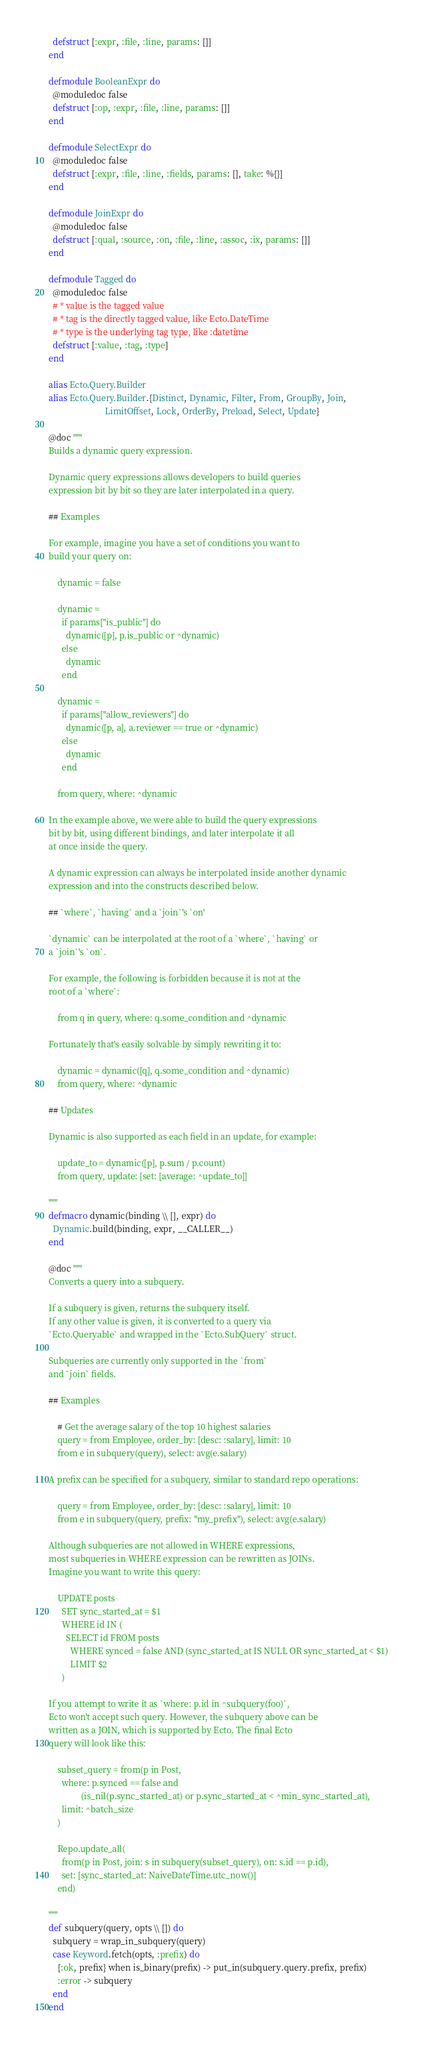Convert code to text. <code><loc_0><loc_0><loc_500><loc_500><_Elixir_>    defstruct [:expr, :file, :line, params: []]
  end

  defmodule BooleanExpr do
    @moduledoc false
    defstruct [:op, :expr, :file, :line, params: []]
  end

  defmodule SelectExpr do
    @moduledoc false
    defstruct [:expr, :file, :line, :fields, params: [], take: %{}]
  end

  defmodule JoinExpr do
    @moduledoc false
    defstruct [:qual, :source, :on, :file, :line, :assoc, :ix, params: []]
  end

  defmodule Tagged do
    @moduledoc false
    # * value is the tagged value
    # * tag is the directly tagged value, like Ecto.DateTime
    # * type is the underlying tag type, like :datetime
    defstruct [:value, :tag, :type]
  end

  alias Ecto.Query.Builder
  alias Ecto.Query.Builder.{Distinct, Dynamic, Filter, From, GroupBy, Join,
                            LimitOffset, Lock, OrderBy, Preload, Select, Update}

  @doc """
  Builds a dynamic query expression.

  Dynamic query expressions allows developers to build queries
  expression bit by bit so they are later interpolated in a query.

  ## Examples

  For example, imagine you have a set of conditions you want to
  build your query on:

      dynamic = false

      dynamic =
        if params["is_public"] do
          dynamic([p], p.is_public or ^dynamic)
        else
          dynamic
        end

      dynamic =
        if params["allow_reviewers"] do
          dynamic([p, a], a.reviewer == true or ^dynamic)
        else
          dynamic
        end

      from query, where: ^dynamic

  In the example above, we were able to build the query expressions
  bit by bit, using different bindings, and later interpolate it all
  at once inside the query.

  A dynamic expression can always be interpolated inside another dynamic
  expression and into the constructs described below.

  ## `where`, `having` and a `join`'s `on'

  `dynamic` can be interpolated at the root of a `where`, `having` or
  a `join`'s `on`.

  For example, the following is forbidden because it is not at the
  root of a `where`:

      from q in query, where: q.some_condition and ^dynamic

  Fortunately that's easily solvable by simply rewriting it to:

      dynamic = dynamic([q], q.some_condition and ^dynamic)
      from query, where: ^dynamic

  ## Updates

  Dynamic is also supported as each field in an update, for example:

      update_to = dynamic([p], p.sum / p.count)
      from query, update: [set: [average: ^update_to]]

  """
  defmacro dynamic(binding \\ [], expr) do
    Dynamic.build(binding, expr, __CALLER__)
  end

  @doc """
  Converts a query into a subquery.

  If a subquery is given, returns the subquery itself.
  If any other value is given, it is converted to a query via
  `Ecto.Queryable` and wrapped in the `Ecto.SubQuery` struct.

  Subqueries are currently only supported in the `from`
  and `join` fields.

  ## Examples

      # Get the average salary of the top 10 highest salaries
      query = from Employee, order_by: [desc: :salary], limit: 10
      from e in subquery(query), select: avg(e.salary)

  A prefix can be specified for a subquery, similar to standard repo operations:

      query = from Employee, order_by: [desc: :salary], limit: 10
      from e in subquery(query, prefix: "my_prefix"), select: avg(e.salary)

  Although subqueries are not allowed in WHERE expressions,
  most subqueries in WHERE expression can be rewritten as JOINs.
  Imagine you want to write this query:

      UPDATE posts
        SET sync_started_at = $1
        WHERE id IN (
          SELECT id FROM posts
            WHERE synced = false AND (sync_started_at IS NULL OR sync_started_at < $1)
            LIMIT $2
        )

  If you attempt to write it as `where: p.id in ^subquery(foo)`,
  Ecto won't accept such query. However, the subquery above can be
  written as a JOIN, which is supported by Ecto. The final Ecto
  query will look like this:

      subset_query = from(p in Post,
        where: p.synced == false and
                 (is_nil(p.sync_started_at) or p.sync_started_at < ^min_sync_started_at),
        limit: ^batch_size
      )

      Repo.update_all(
        from(p in Post, join: s in subquery(subset_query), on: s.id == p.id),
        set: [sync_started_at: NaiveDateTime.utc_now()]
      end)

  """
  def subquery(query, opts \\ []) do
    subquery = wrap_in_subquery(query)
    case Keyword.fetch(opts, :prefix) do
      {:ok, prefix} when is_binary(prefix) -> put_in(subquery.query.prefix, prefix)
      :error -> subquery
    end
  end
</code> 